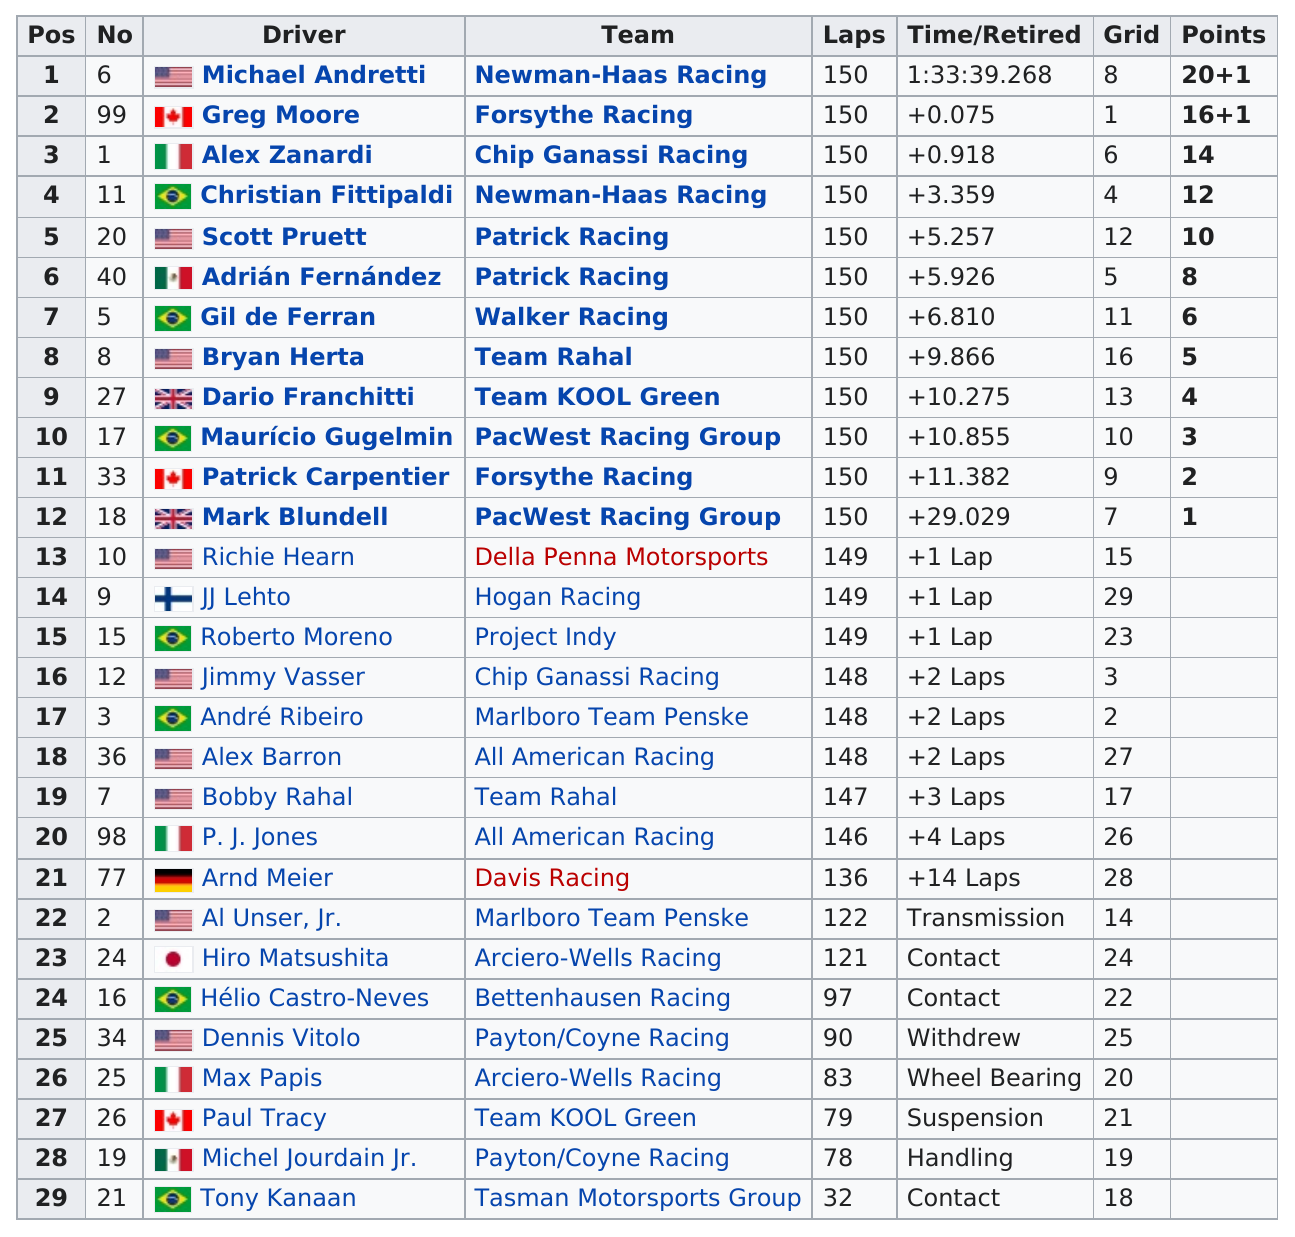Draw attention to some important aspects in this diagram. Twelve teams successfully completed all 150 laps of the 1998 Marlboro Grand Prix of Miami. Nine American drivers participated in the race. I am sorry, but the sentence "how many canadian drivers finished in at least 10th position or better? 1.. The total number of drivers who did not finish the race was 17. The driver who finished first in the 1998 Marlboro Grand Prix of Miami was Michael Andretti. 